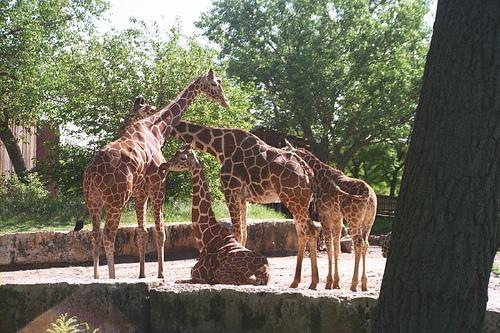How many giraffes are standing in the middle of the stone enclosure?

Choices:
A) one
B) two
C) three
D) four four 